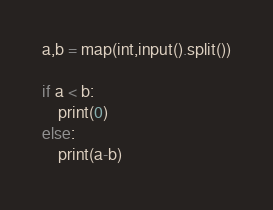Convert code to text. <code><loc_0><loc_0><loc_500><loc_500><_Python_>a,b = map(int,input().split())

if a < b:
    print(0)
else:
    print(a-b)</code> 